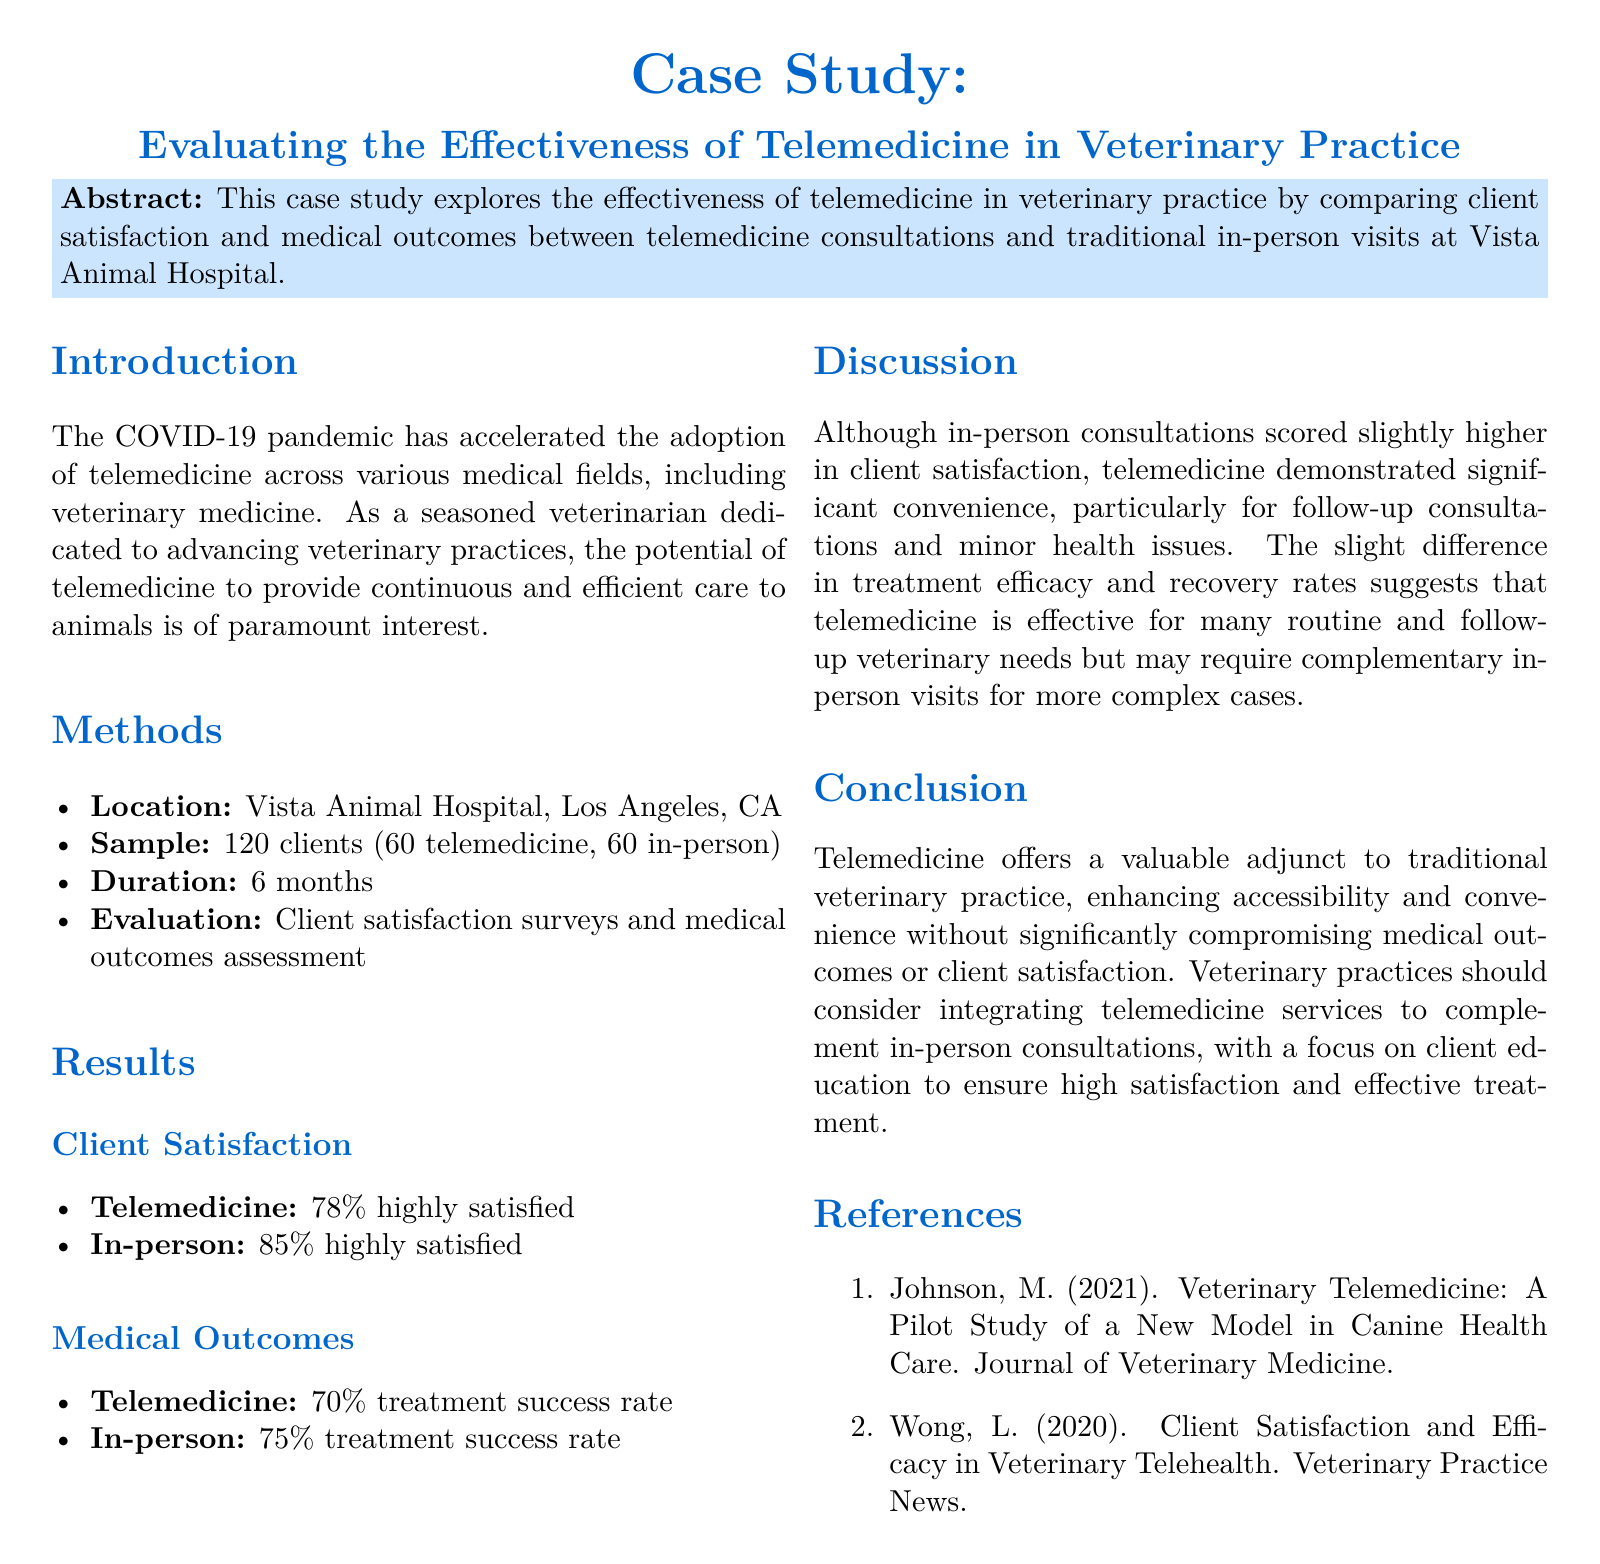what is the location of the study? The location of the study is specified as Vista Animal Hospital, Los Angeles, CA.
Answer: Vista Animal Hospital, Los Angeles, CA how many clients participated in the study? The study involved a sample of 120 clients.
Answer: 120 clients what was the duration of the study? The study lasted for 6 months as stated in the methods section.
Answer: 6 months what percentage of telemedicine clients reported high satisfaction? According to the results, 78% of telemedicine clients reported being highly satisfied.
Answer: 78% what was the treatment success rate for in-person consultations? The document states that the treatment success rate for in-person consultations was 75%.
Answer: 75% which method scored higher in client satisfaction? The results indicate that in-person consultations scored higher in client satisfaction than telemedicine.
Answer: in-person what is one benefit of telemedicine mentioned in the discussion? The discussion highlights the significant convenience of telemedicine, especially for follow-up consultations and minor health issues.
Answer: convenience how does telemedicine compare to in-person consultations regarding medical outcomes? Telemedicine demonstrated a treatment success rate of 70%, which is slightly lower than the 75% for in-person consultations.
Answer: lower what is the primary focus suggested for integrating telemedicine services? The conclusion emphasizes the need to focus on client education to ensure high satisfaction and effective treatment.
Answer: client education 